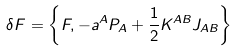<formula> <loc_0><loc_0><loc_500><loc_500>\delta F = \left \{ F , - a ^ { A } P _ { A } + \frac { 1 } { 2 } K ^ { A B } J _ { A B } \right \}</formula> 